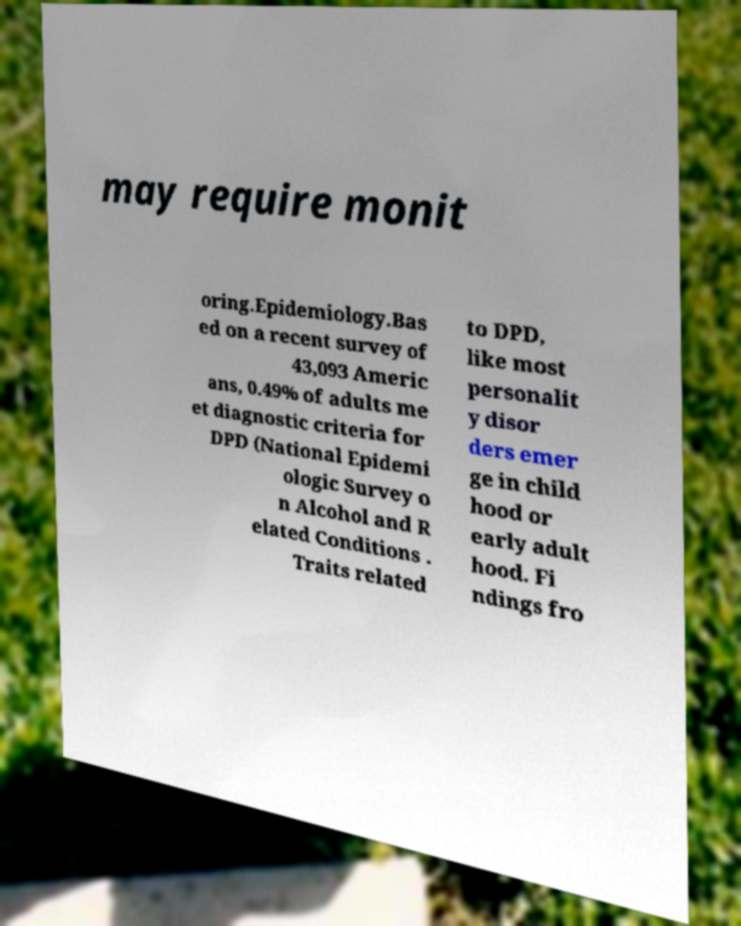There's text embedded in this image that I need extracted. Can you transcribe it verbatim? may require monit oring.Epidemiology.Bas ed on a recent survey of 43,093 Americ ans, 0.49% of adults me et diagnostic criteria for DPD (National Epidemi ologic Survey o n Alcohol and R elated Conditions . Traits related to DPD, like most personalit y disor ders emer ge in child hood or early adult hood. Fi ndings fro 